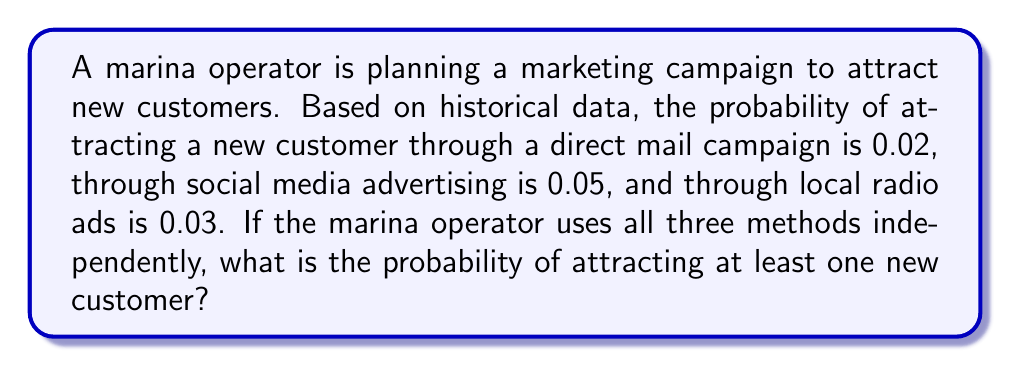Solve this math problem. To solve this problem, we need to use the concept of probability of independent events and the complement rule.

1. First, let's define our events:
   A: Attracting a customer through direct mail
   B: Attracting a customer through social media
   C: Attracting a customer through radio ads

2. We're given the following probabilities:
   $P(A) = 0.02$
   $P(B) = 0.05$
   $P(C) = 0.03$

3. We want to find the probability of attracting at least one new customer, which is the complement of attracting no customers at all.

4. The probability of not attracting a customer through each method:
   $P(\text{not A}) = 1 - P(A) = 1 - 0.02 = 0.98$
   $P(\text{not B}) = 1 - P(B) = 1 - 0.05 = 0.95$
   $P(\text{not C}) = 1 - P(C) = 1 - 0.03 = 0.97$

5. The probability of not attracting any customers (the complement of what we're looking for):
   $P(\text{no customers}) = P(\text{not A}) \times P(\text{not B}) \times P(\text{not C})$
   $P(\text{no customers}) = 0.98 \times 0.95 \times 0.97 = 0.9018$

6. Therefore, the probability of attracting at least one new customer is:
   $P(\text{at least one}) = 1 - P(\text{no customers})$
   $P(\text{at least one}) = 1 - 0.9018 = 0.0982$
Answer: The probability of attracting at least one new customer is approximately $0.0982$ or $9.82\%$. 